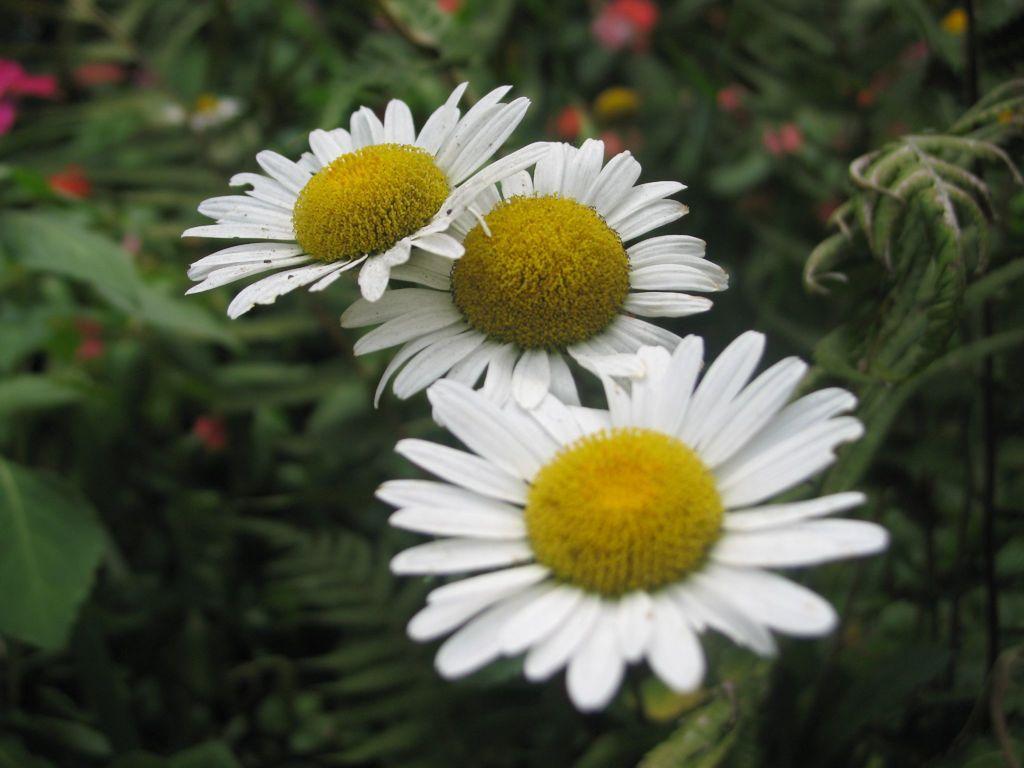How would you summarize this image in a sentence or two? In this picture there are three sunflowers. On the top we can see red flowers. on the left there is a plant. 